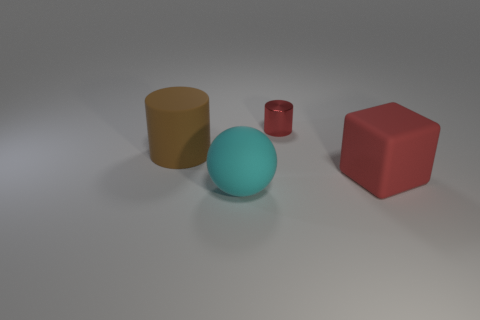What material is the large object that is the same color as the small metallic thing?
Keep it short and to the point. Rubber. What number of tiny things have the same color as the rubber cube?
Give a very brief answer. 1. Does the brown rubber object have the same size as the cylinder to the right of the cyan ball?
Make the answer very short. No. There is a object on the left side of the thing that is in front of the big object right of the rubber sphere; how big is it?
Give a very brief answer. Large. There is a big rubber cylinder; how many large rubber objects are in front of it?
Provide a short and direct response. 2. What is the material of the cylinder that is to the right of the cylinder in front of the tiny object?
Your answer should be compact. Metal. Is there anything else that is the same size as the shiny cylinder?
Provide a short and direct response. No. Do the red matte thing and the cyan object have the same size?
Your answer should be very brief. Yes. How many things are matte cylinders that are behind the large rubber ball or big things to the left of the cyan rubber ball?
Keep it short and to the point. 1. Are there more large brown cylinders in front of the metal cylinder than tiny red rubber objects?
Your answer should be very brief. Yes. 